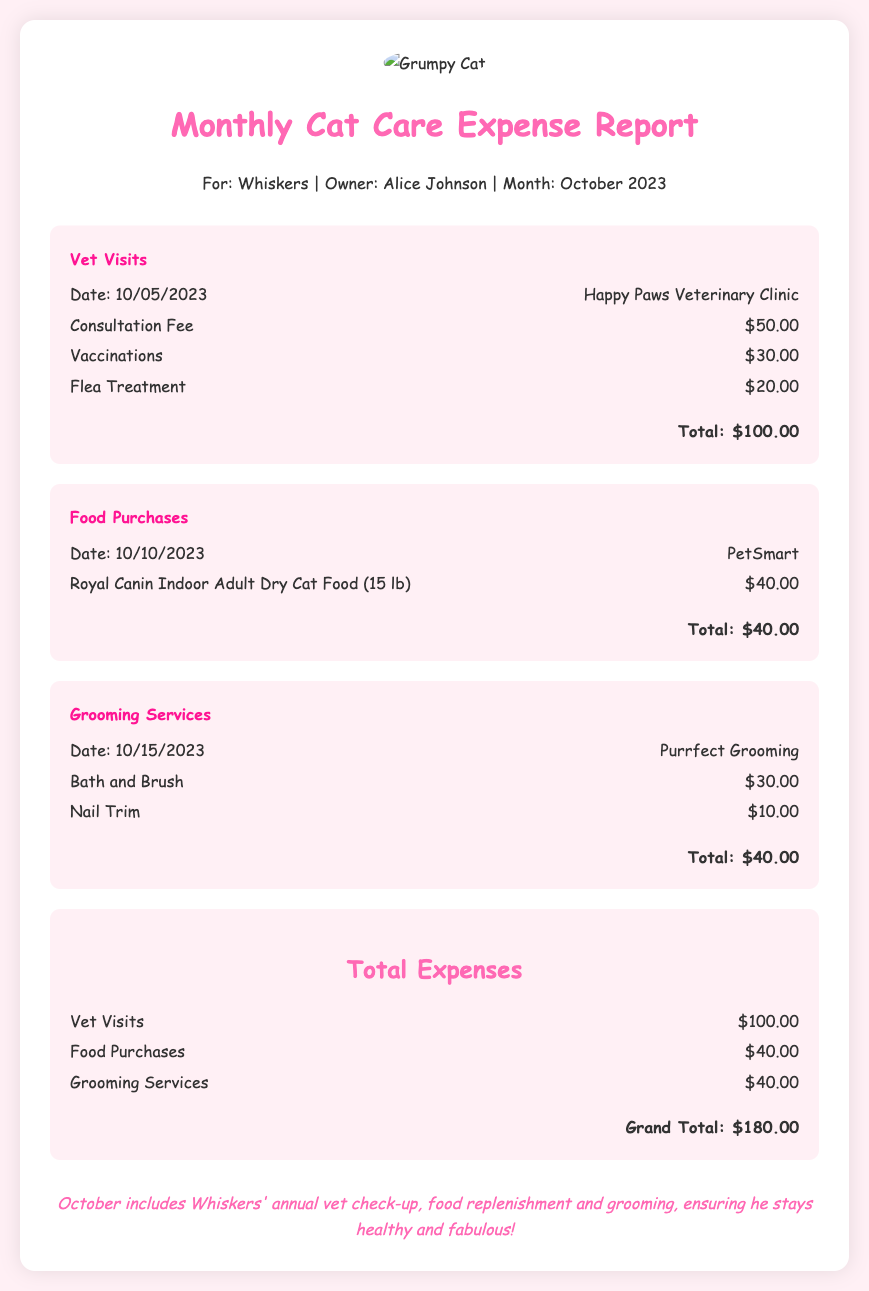what is the total expense for vet visits? The total expense for vet visits is listed in the expense section under "Vet Visits," which details all associated costs.
Answer: $100.00 what is the name of the grooming service? The name of the grooming service is provided in the "Grooming Services" section of the report.
Answer: Purrfect Grooming when was the food purchased? The purchase date for the food is given in the "Food Purchases" section.
Answer: 10/10/2023 what is the grand total for all expenses? The grand total for all expenses is calculated by summing each expense category stated in the document.
Answer: $180.00 how much was spent on the flea treatment? The cost for flea treatment is detailed in the "Vet Visits" section.
Answer: $20.00 which clinic did Whiskers visit for his vet appointment? The clinic name is mentioned directly after the date of the vet visit.
Answer: Happy Paws Veterinary Clinic what services were included in the grooming expenses? The services received are listed in the "Grooming Services" section of the document.
Answer: Bath and Brush, Nail Trim who is the owner listed in the report? The owner's name is provided in the header of the document.
Answer: Alice Johnson what is the date of Whiskers' vet visit? The date of the vet visit is specified in the "Vet Visits" section of the report.
Answer: 10/05/2023 